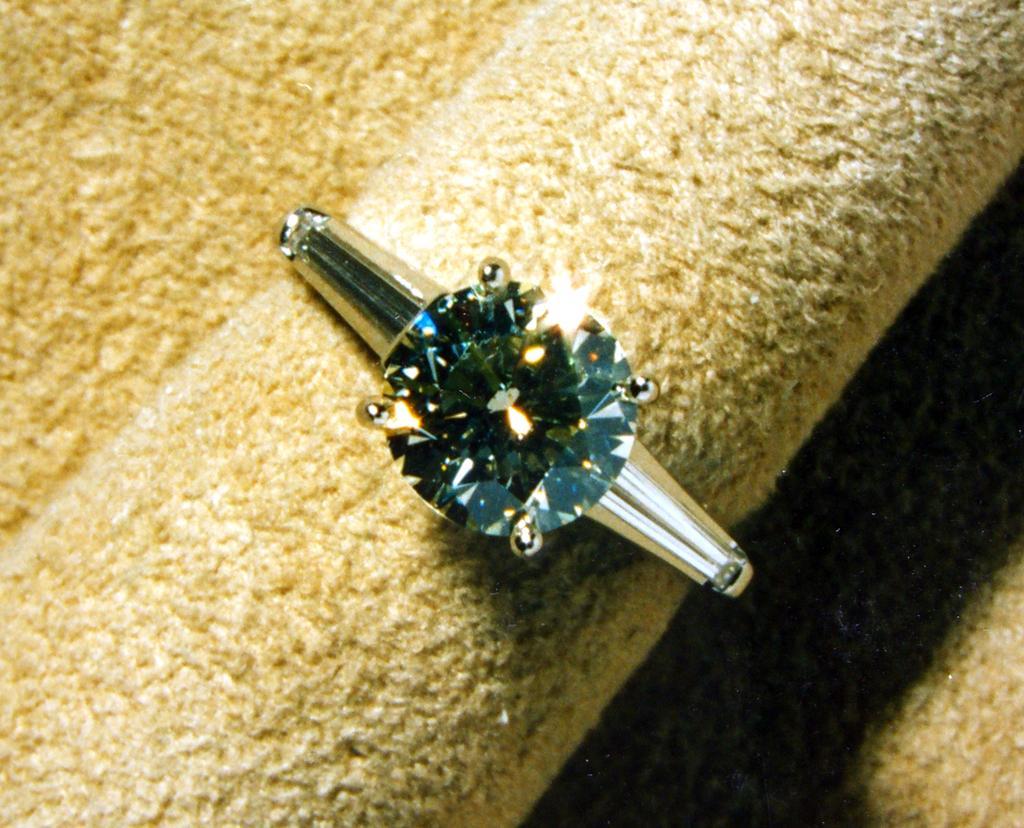Could you give a brief overview of what you see in this image? In this image we can see a ring. At the bottom of the image there is a cloth. 